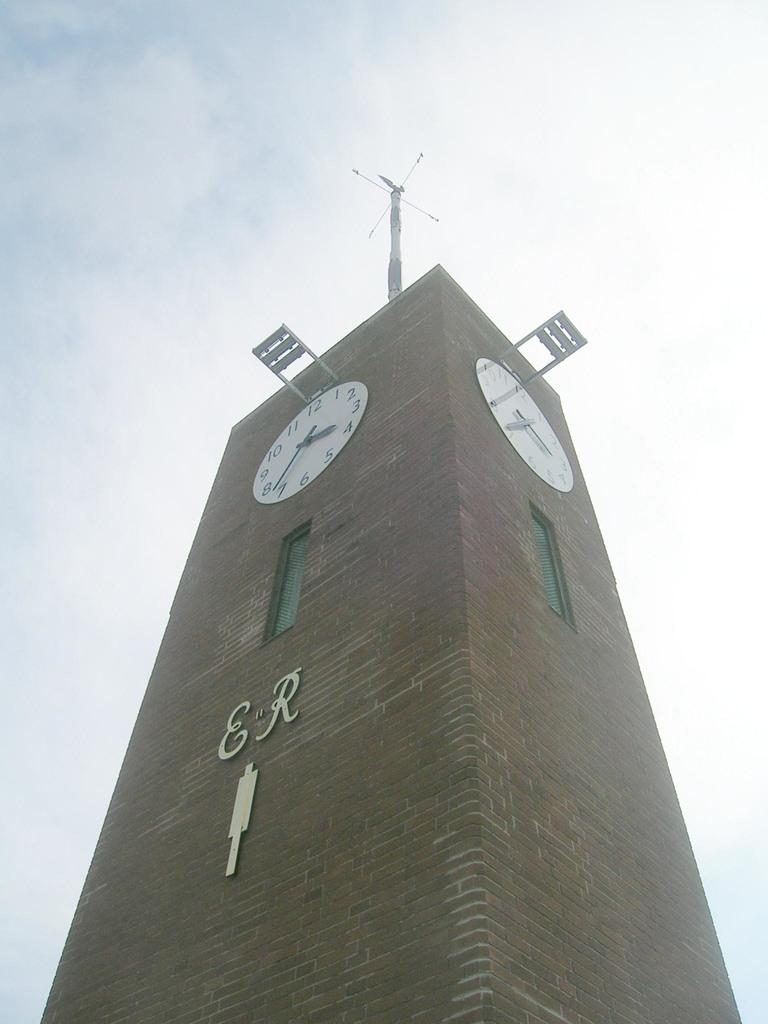What is the main structure in the center of the image? There is a tower in the center of the image. What features can be seen on the tower? The tower has clocks, text, and an antenna. What can be seen in the background of the image? The sky is visible in the background of the image. How many worms can be seen crawling on the tower in the image? There are no worms present on the tower in the image. What type of rod is used to support the antenna on the tower? There is no information about the type of rod used to support the antenna on the tower in the image. 